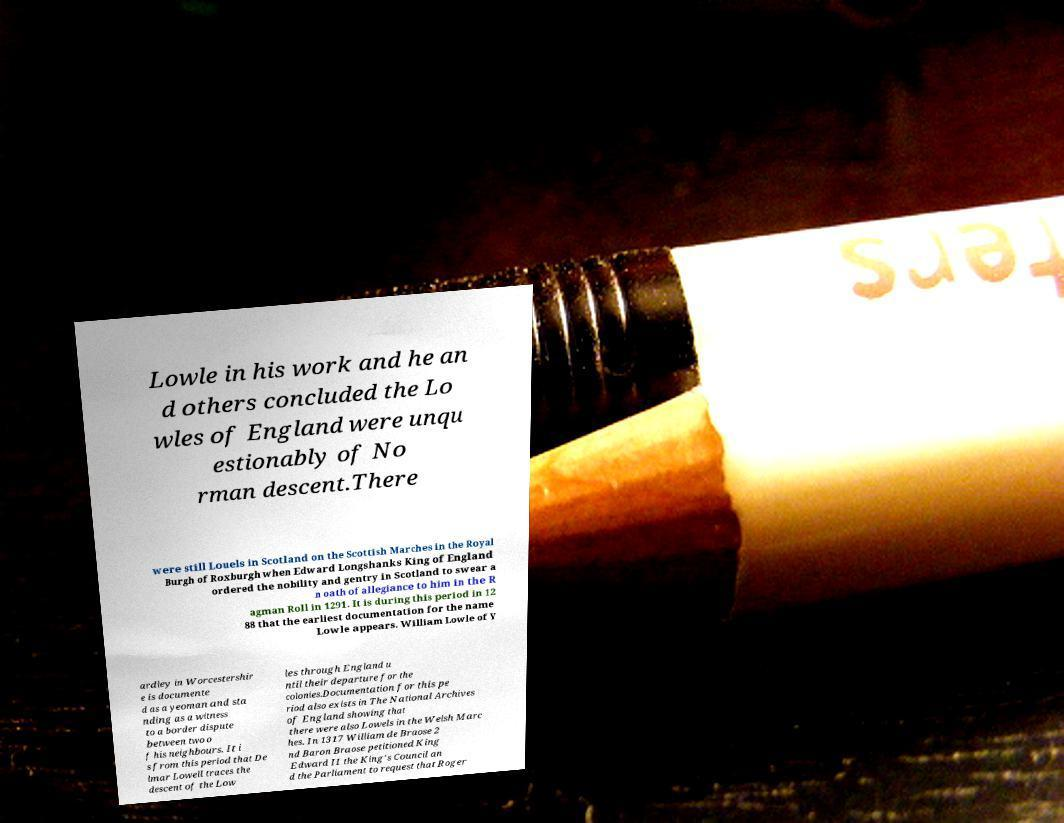Please read and relay the text visible in this image. What does it say? Lowle in his work and he an d others concluded the Lo wles of England were unqu estionably of No rman descent.There were still Louels in Scotland on the Scottish Marches in the Royal Burgh of Roxburgh when Edward Longshanks King of England ordered the nobility and gentry in Scotland to swear a n oath of allegiance to him in the R agman Roll in 1291. It is during this period in 12 88 that the earliest documentation for the name Lowle appears. William Lowle of Y ardley in Worcestershir e is documente d as a yeoman and sta nding as a witness to a border dispute between two o f his neighbours. It i s from this period that De lmar Lowell traces the descent of the Low les through England u ntil their departure for the colonies.Documentation for this pe riod also exists in The National Archives of England showing that there were also Lowels in the Welsh Marc hes. In 1317 William de Braose 2 nd Baron Braose petitioned King Edward II the King's Council an d the Parliament to request that Roger 